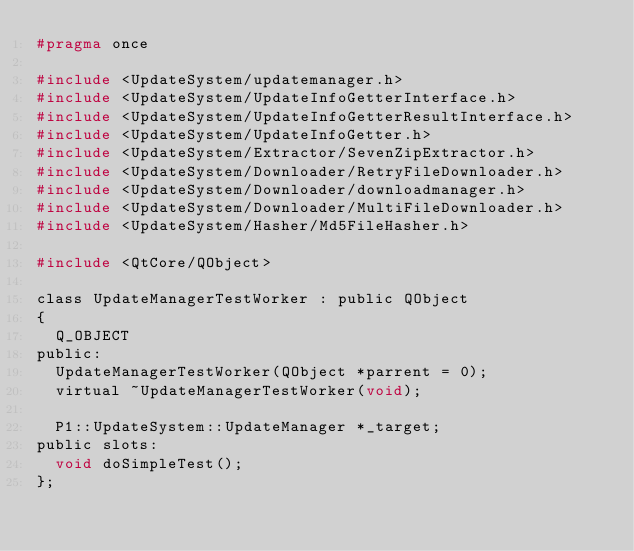<code> <loc_0><loc_0><loc_500><loc_500><_C_>#pragma once

#include <UpdateSystem/updatemanager.h>
#include <UpdateSystem/UpdateInfoGetterInterface.h>
#include <UpdateSystem/UpdateInfoGetterResultInterface.h>
#include <UpdateSystem/UpdateInfoGetter.h>
#include <UpdateSystem/Extractor/SevenZipExtractor.h>
#include <UpdateSystem/Downloader/RetryFileDownloader.h>
#include <UpdateSystem/Downloader/downloadmanager.h>
#include <UpdateSystem/Downloader/MultiFileDownloader.h>
#include <UpdateSystem/Hasher/Md5FileHasher.h>

#include <QtCore/QObject>

class UpdateManagerTestWorker : public QObject
{
  Q_OBJECT
public:
  UpdateManagerTestWorker(QObject *parrent = 0);
  virtual ~UpdateManagerTestWorker(void);

  P1::UpdateSystem::UpdateManager *_target;
public slots:
  void doSimpleTest();
};
</code> 